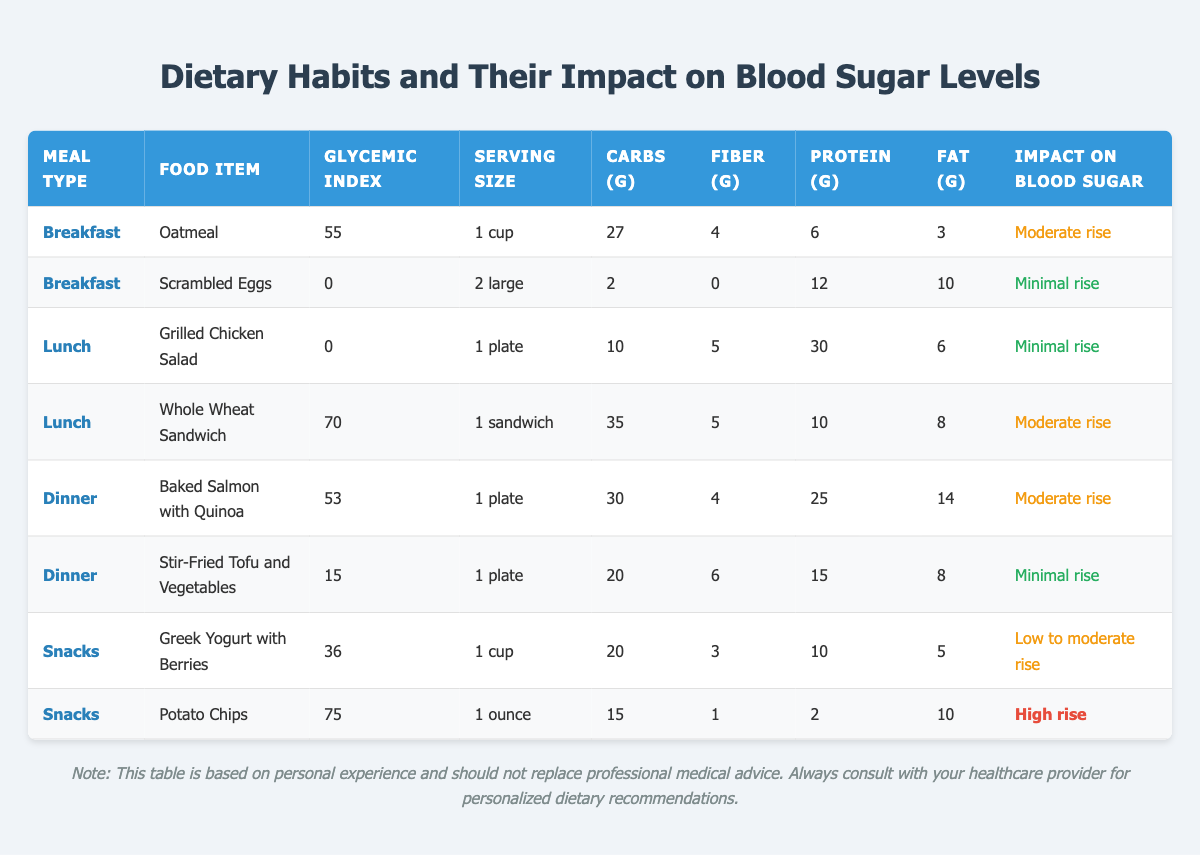What is the glycemic index of Oatmeal? The glycemic index of Oatmeal is provided in the row for Breakfast, which states it as 55.
Answer: 55 Which meal has the food item with the highest impact on blood sugar? The table shows that Potato Chips have the highest impact on blood sugar with a classification of "High rise." This is found in the Snacks section.
Answer: Potato Chips How many grams of carbohydrates are in a Whole Wheat Sandwich? The carbohydrate content for a Whole Wheat Sandwich is listed in the Lunch section, where it states that it contains 35 grams of carbohydrates.
Answer: 35 grams What is the average glycemic index of the Dinner meal type? The Dinner meal type has two food items: Baked Salmon with Quinoa (53) and Stir-Fried Tofu and Vegetables (15). The sum is 53 + 15 = 68, and there are 2 items, so the average is 68/2 = 34.
Answer: 34 Is the impact on blood sugar for Scrambled Eggs minimal? The table classifies the impact on blood sugar for Scrambled Eggs as "Minimal rise," confirming that the statement is true.
Answer: Yes Which food item has the highest protein content, and what is its value? Examining the table, Grilled Chicken Salad has the highest protein content listed at 30 grams, found in the Lunch section.
Answer: 30 grams How does the impact on blood sugar compare between Oatmeal and Potato Chips? The table shows that Oatmeal has a "Moderate rise" impact while Potato Chips have a "High rise," indicating that Potato Chips have a more significant effect on blood sugar compared to Oatmeal.
Answer: Potato Chips have a higher impact What is the total protein content of the food items listed under Lunch? The Lunch food items are Grilled Chicken Salad (30g) and Whole Wheat Sandwich (10g). Adding them gives 30 + 10 = 40 grams of protein total.
Answer: 40 grams Do both meals categorized under Breakfast cause a minimal rise in blood sugar? The table shows that Oatmeal causes a "Moderate rise" while Scrambled Eggs cause a "Minimal rise," making the statement false.
Answer: No Which snacks have a low to moderate rise in blood sugar? The table lists Greek Yogurt with Berries as having a "Low to moderate rise" but Potato Chips with a "High rise." Therefore, only Greek Yogurt with Berries fits the criteria.
Answer: Greek Yogurt with Berries 